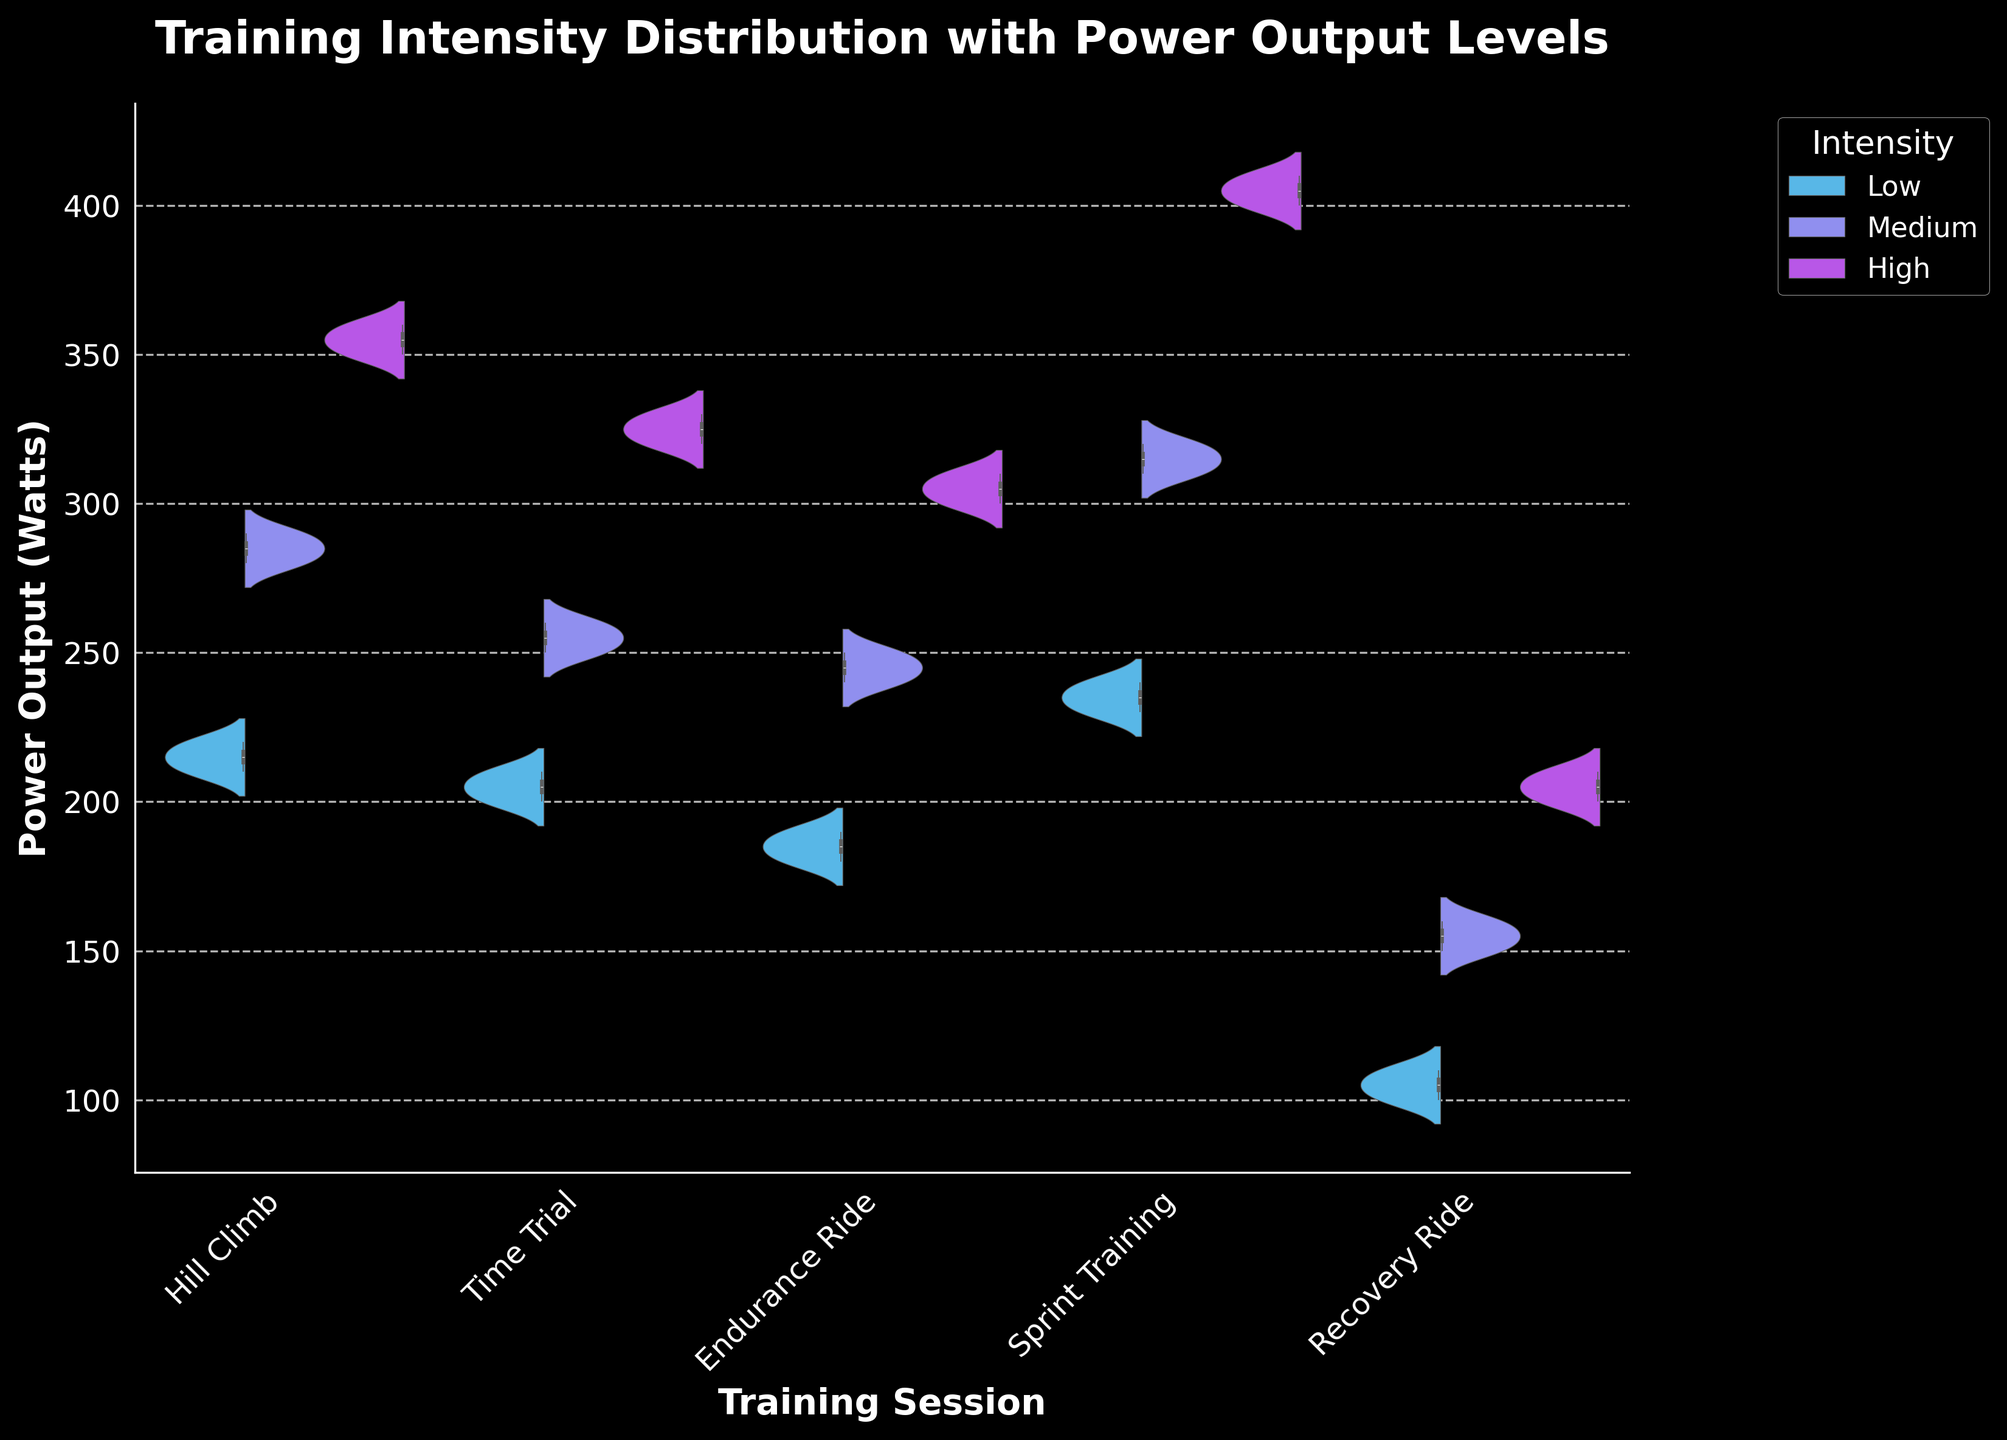What is the title of the figure? The title is given at the top of the figure and is meant to describe what the visual representation is about.
Answer: Training Intensity Distribution with Power Output Levels Which training session has the highest maximum power output? The highest peak in the figure represents the session with the highest maximum power output.
Answer: Sprint Training What is the shape of the power output distribution for Hill Climb sessions? The shape of the violin plot for Hill Climb indicates the distribution of power outputs.
Answer: Bimodal with peaks at Medium and High intensity Which training session has the widest range of power outputs in the Medium intensity category? By comparing the width of the violins for Medium intensity in different sessions, the widest range can be identified.
Answer: Sprint Training How does the median power output of Recovery Ride compared to Hill Climb in the Low intensity category? Observing the line within the box plot part of the violin chart for both sessions, the median values can be compared.
Answer: Lower for Recovery Ride Which intensity level shows the most variation in power output across all training sessions? The width and spread of the violins for each intensity level across sessions will indicate the level of variation.
Answer: High What is the median power output for Medium intensity during Endurance Ride sessions? The median is represented by the middle line in the box plot inside the violin for Medium intensity in Endurance Ride.
Answer: 245 Watts Which training session has the smallest interquartile range (IQR) in the High intensity category? The IQR is the range between the lower and upper quartiles represented by the box plot inside the violin. Looking for the smallest box in High intensity across sessions, identify the session.
Answer: Recovery Ride Are the median power outputs for Medium intensity in Time Trial and Endurance Ride sessions equal? By observing the middle line in the box plots for Medium intensity in both sessions, we can determine if they are at the same level.
Answer: No How do the power output distributions for Low intensity compare across the different training sessions? By comparing the shapes and widths of the violins for Low intensity in each session, similarities and differences in their distributions can be assessed.
Answer: They vary, with Recovery Ride having the lowest, and Sprint Training having the highest values 